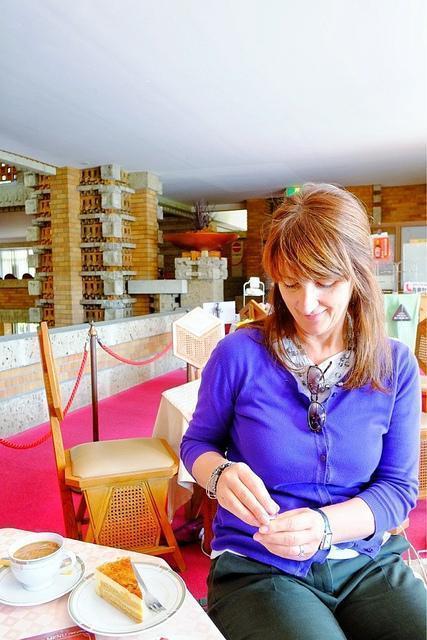Why is the woman sitting?
From the following four choices, select the correct answer to address the question.
Options: To eat, tie shoes, have conversation, to work. To eat. 